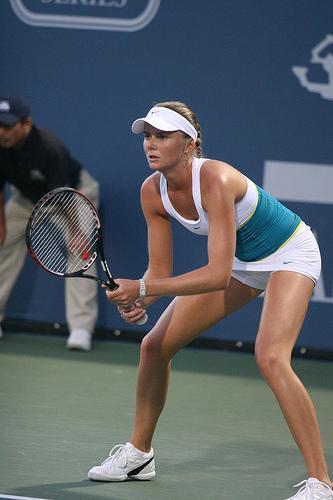How many players are pictured?
Give a very brief answer. 1. 